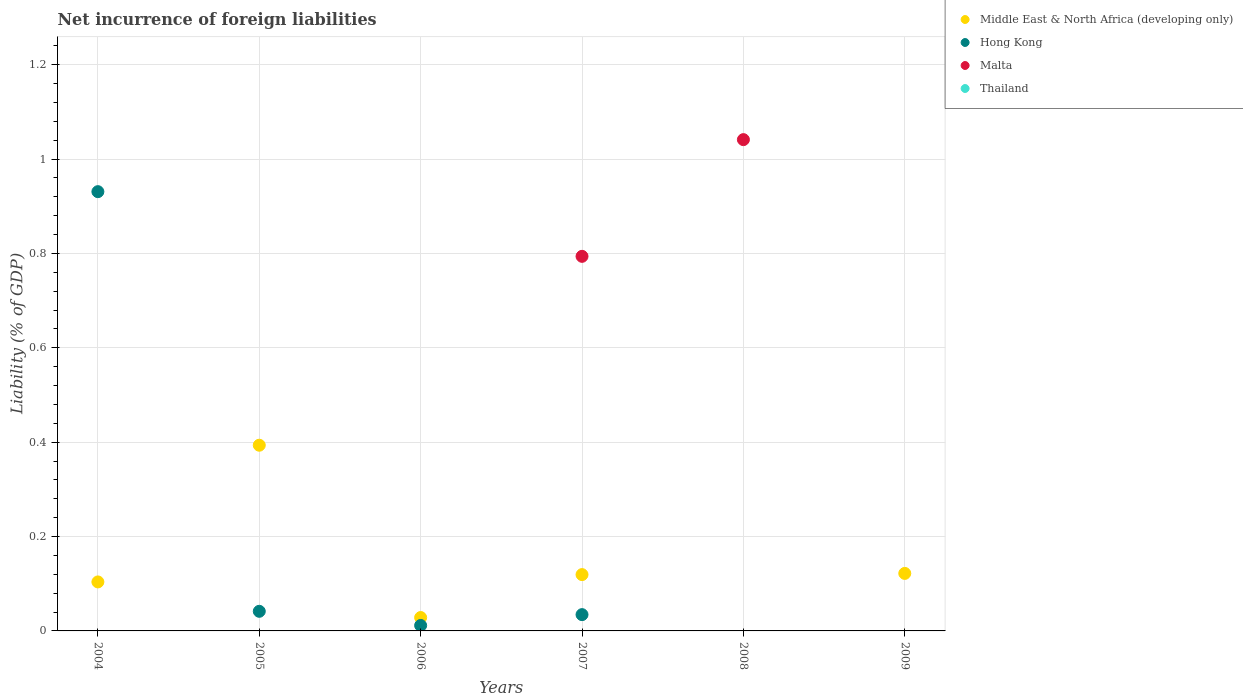How many different coloured dotlines are there?
Your response must be concise. 3. Is the number of dotlines equal to the number of legend labels?
Keep it short and to the point. No. What is the net incurrence of foreign liabilities in Middle East & North Africa (developing only) in 2004?
Your answer should be very brief. 0.1. Across all years, what is the maximum net incurrence of foreign liabilities in Malta?
Your response must be concise. 1.04. In which year was the net incurrence of foreign liabilities in Hong Kong maximum?
Offer a very short reply. 2004. What is the total net incurrence of foreign liabilities in Middle East & North Africa (developing only) in the graph?
Your answer should be compact. 0.77. What is the difference between the net incurrence of foreign liabilities in Middle East & North Africa (developing only) in 2004 and that in 2007?
Your answer should be compact. -0.02. What is the difference between the net incurrence of foreign liabilities in Middle East & North Africa (developing only) in 2006 and the net incurrence of foreign liabilities in Hong Kong in 2007?
Ensure brevity in your answer.  -0.01. What is the average net incurrence of foreign liabilities in Middle East & North Africa (developing only) per year?
Ensure brevity in your answer.  0.13. In the year 2007, what is the difference between the net incurrence of foreign liabilities in Middle East & North Africa (developing only) and net incurrence of foreign liabilities in Hong Kong?
Give a very brief answer. 0.08. What is the ratio of the net incurrence of foreign liabilities in Middle East & North Africa (developing only) in 2004 to that in 2007?
Offer a terse response. 0.87. Is the net incurrence of foreign liabilities in Middle East & North Africa (developing only) in 2005 less than that in 2009?
Your answer should be compact. No. What is the difference between the highest and the second highest net incurrence of foreign liabilities in Hong Kong?
Give a very brief answer. 0.89. What is the difference between the highest and the lowest net incurrence of foreign liabilities in Middle East & North Africa (developing only)?
Offer a very short reply. 0.39. Is the sum of the net incurrence of foreign liabilities in Hong Kong in 2006 and 2007 greater than the maximum net incurrence of foreign liabilities in Malta across all years?
Offer a terse response. No. Is it the case that in every year, the sum of the net incurrence of foreign liabilities in Thailand and net incurrence of foreign liabilities in Malta  is greater than the sum of net incurrence of foreign liabilities in Hong Kong and net incurrence of foreign liabilities in Middle East & North Africa (developing only)?
Your answer should be very brief. No. Does the net incurrence of foreign liabilities in Malta monotonically increase over the years?
Provide a short and direct response. No. What is the difference between two consecutive major ticks on the Y-axis?
Make the answer very short. 0.2. Does the graph contain any zero values?
Your answer should be very brief. Yes. Where does the legend appear in the graph?
Provide a succinct answer. Top right. How many legend labels are there?
Provide a succinct answer. 4. How are the legend labels stacked?
Ensure brevity in your answer.  Vertical. What is the title of the graph?
Your answer should be very brief. Net incurrence of foreign liabilities. Does "El Salvador" appear as one of the legend labels in the graph?
Provide a succinct answer. No. What is the label or title of the Y-axis?
Offer a very short reply. Liability (% of GDP). What is the Liability (% of GDP) in Middle East & North Africa (developing only) in 2004?
Your answer should be very brief. 0.1. What is the Liability (% of GDP) of Hong Kong in 2004?
Provide a succinct answer. 0.93. What is the Liability (% of GDP) of Middle East & North Africa (developing only) in 2005?
Give a very brief answer. 0.39. What is the Liability (% of GDP) of Hong Kong in 2005?
Provide a succinct answer. 0.04. What is the Liability (% of GDP) in Thailand in 2005?
Offer a terse response. 0. What is the Liability (% of GDP) of Middle East & North Africa (developing only) in 2006?
Offer a terse response. 0.03. What is the Liability (% of GDP) of Hong Kong in 2006?
Offer a very short reply. 0.01. What is the Liability (% of GDP) of Thailand in 2006?
Give a very brief answer. 0. What is the Liability (% of GDP) of Middle East & North Africa (developing only) in 2007?
Your answer should be compact. 0.12. What is the Liability (% of GDP) in Hong Kong in 2007?
Provide a succinct answer. 0.03. What is the Liability (% of GDP) in Malta in 2007?
Your response must be concise. 0.79. What is the Liability (% of GDP) in Middle East & North Africa (developing only) in 2008?
Offer a terse response. 0. What is the Liability (% of GDP) of Hong Kong in 2008?
Offer a very short reply. 0. What is the Liability (% of GDP) in Malta in 2008?
Offer a terse response. 1.04. What is the Liability (% of GDP) in Middle East & North Africa (developing only) in 2009?
Your response must be concise. 0.12. What is the Liability (% of GDP) of Hong Kong in 2009?
Keep it short and to the point. 0. Across all years, what is the maximum Liability (% of GDP) in Middle East & North Africa (developing only)?
Your answer should be very brief. 0.39. Across all years, what is the maximum Liability (% of GDP) in Hong Kong?
Your answer should be very brief. 0.93. Across all years, what is the maximum Liability (% of GDP) in Malta?
Ensure brevity in your answer.  1.04. Across all years, what is the minimum Liability (% of GDP) of Middle East & North Africa (developing only)?
Your response must be concise. 0. What is the total Liability (% of GDP) in Middle East & North Africa (developing only) in the graph?
Keep it short and to the point. 0.77. What is the total Liability (% of GDP) in Hong Kong in the graph?
Ensure brevity in your answer.  1.02. What is the total Liability (% of GDP) of Malta in the graph?
Give a very brief answer. 1.84. What is the difference between the Liability (% of GDP) of Middle East & North Africa (developing only) in 2004 and that in 2005?
Offer a very short reply. -0.29. What is the difference between the Liability (% of GDP) of Hong Kong in 2004 and that in 2005?
Ensure brevity in your answer.  0.89. What is the difference between the Liability (% of GDP) of Middle East & North Africa (developing only) in 2004 and that in 2006?
Make the answer very short. 0.08. What is the difference between the Liability (% of GDP) of Hong Kong in 2004 and that in 2006?
Offer a very short reply. 0.92. What is the difference between the Liability (% of GDP) in Middle East & North Africa (developing only) in 2004 and that in 2007?
Ensure brevity in your answer.  -0.02. What is the difference between the Liability (% of GDP) of Hong Kong in 2004 and that in 2007?
Provide a succinct answer. 0.9. What is the difference between the Liability (% of GDP) of Middle East & North Africa (developing only) in 2004 and that in 2009?
Make the answer very short. -0.02. What is the difference between the Liability (% of GDP) in Middle East & North Africa (developing only) in 2005 and that in 2006?
Keep it short and to the point. 0.37. What is the difference between the Liability (% of GDP) of Hong Kong in 2005 and that in 2006?
Your answer should be very brief. 0.03. What is the difference between the Liability (% of GDP) in Middle East & North Africa (developing only) in 2005 and that in 2007?
Your answer should be compact. 0.27. What is the difference between the Liability (% of GDP) in Hong Kong in 2005 and that in 2007?
Offer a very short reply. 0.01. What is the difference between the Liability (% of GDP) in Middle East & North Africa (developing only) in 2005 and that in 2009?
Keep it short and to the point. 0.27. What is the difference between the Liability (% of GDP) of Middle East & North Africa (developing only) in 2006 and that in 2007?
Give a very brief answer. -0.09. What is the difference between the Liability (% of GDP) in Hong Kong in 2006 and that in 2007?
Make the answer very short. -0.02. What is the difference between the Liability (% of GDP) in Middle East & North Africa (developing only) in 2006 and that in 2009?
Your response must be concise. -0.09. What is the difference between the Liability (% of GDP) in Malta in 2007 and that in 2008?
Give a very brief answer. -0.25. What is the difference between the Liability (% of GDP) of Middle East & North Africa (developing only) in 2007 and that in 2009?
Give a very brief answer. -0. What is the difference between the Liability (% of GDP) in Middle East & North Africa (developing only) in 2004 and the Liability (% of GDP) in Hong Kong in 2005?
Offer a very short reply. 0.06. What is the difference between the Liability (% of GDP) of Middle East & North Africa (developing only) in 2004 and the Liability (% of GDP) of Hong Kong in 2006?
Your response must be concise. 0.09. What is the difference between the Liability (% of GDP) of Middle East & North Africa (developing only) in 2004 and the Liability (% of GDP) of Hong Kong in 2007?
Provide a short and direct response. 0.07. What is the difference between the Liability (% of GDP) of Middle East & North Africa (developing only) in 2004 and the Liability (% of GDP) of Malta in 2007?
Provide a succinct answer. -0.69. What is the difference between the Liability (% of GDP) in Hong Kong in 2004 and the Liability (% of GDP) in Malta in 2007?
Offer a very short reply. 0.14. What is the difference between the Liability (% of GDP) in Middle East & North Africa (developing only) in 2004 and the Liability (% of GDP) in Malta in 2008?
Your answer should be compact. -0.94. What is the difference between the Liability (% of GDP) of Hong Kong in 2004 and the Liability (% of GDP) of Malta in 2008?
Your answer should be very brief. -0.11. What is the difference between the Liability (% of GDP) of Middle East & North Africa (developing only) in 2005 and the Liability (% of GDP) of Hong Kong in 2006?
Give a very brief answer. 0.38. What is the difference between the Liability (% of GDP) in Middle East & North Africa (developing only) in 2005 and the Liability (% of GDP) in Hong Kong in 2007?
Provide a succinct answer. 0.36. What is the difference between the Liability (% of GDP) in Middle East & North Africa (developing only) in 2005 and the Liability (% of GDP) in Malta in 2007?
Ensure brevity in your answer.  -0.4. What is the difference between the Liability (% of GDP) in Hong Kong in 2005 and the Liability (% of GDP) in Malta in 2007?
Provide a succinct answer. -0.75. What is the difference between the Liability (% of GDP) of Middle East & North Africa (developing only) in 2005 and the Liability (% of GDP) of Malta in 2008?
Provide a short and direct response. -0.65. What is the difference between the Liability (% of GDP) of Hong Kong in 2005 and the Liability (% of GDP) of Malta in 2008?
Your answer should be compact. -1. What is the difference between the Liability (% of GDP) of Middle East & North Africa (developing only) in 2006 and the Liability (% of GDP) of Hong Kong in 2007?
Offer a terse response. -0.01. What is the difference between the Liability (% of GDP) in Middle East & North Africa (developing only) in 2006 and the Liability (% of GDP) in Malta in 2007?
Give a very brief answer. -0.77. What is the difference between the Liability (% of GDP) in Hong Kong in 2006 and the Liability (% of GDP) in Malta in 2007?
Offer a terse response. -0.78. What is the difference between the Liability (% of GDP) of Middle East & North Africa (developing only) in 2006 and the Liability (% of GDP) of Malta in 2008?
Ensure brevity in your answer.  -1.01. What is the difference between the Liability (% of GDP) in Hong Kong in 2006 and the Liability (% of GDP) in Malta in 2008?
Give a very brief answer. -1.03. What is the difference between the Liability (% of GDP) in Middle East & North Africa (developing only) in 2007 and the Liability (% of GDP) in Malta in 2008?
Offer a very short reply. -0.92. What is the difference between the Liability (% of GDP) in Hong Kong in 2007 and the Liability (% of GDP) in Malta in 2008?
Offer a terse response. -1.01. What is the average Liability (% of GDP) in Middle East & North Africa (developing only) per year?
Your response must be concise. 0.13. What is the average Liability (% of GDP) of Hong Kong per year?
Make the answer very short. 0.17. What is the average Liability (% of GDP) in Malta per year?
Provide a short and direct response. 0.31. In the year 2004, what is the difference between the Liability (% of GDP) of Middle East & North Africa (developing only) and Liability (% of GDP) of Hong Kong?
Your answer should be compact. -0.83. In the year 2005, what is the difference between the Liability (% of GDP) in Middle East & North Africa (developing only) and Liability (% of GDP) in Hong Kong?
Offer a terse response. 0.35. In the year 2006, what is the difference between the Liability (% of GDP) in Middle East & North Africa (developing only) and Liability (% of GDP) in Hong Kong?
Make the answer very short. 0.02. In the year 2007, what is the difference between the Liability (% of GDP) in Middle East & North Africa (developing only) and Liability (% of GDP) in Hong Kong?
Offer a very short reply. 0.08. In the year 2007, what is the difference between the Liability (% of GDP) in Middle East & North Africa (developing only) and Liability (% of GDP) in Malta?
Provide a succinct answer. -0.67. In the year 2007, what is the difference between the Liability (% of GDP) of Hong Kong and Liability (% of GDP) of Malta?
Give a very brief answer. -0.76. What is the ratio of the Liability (% of GDP) of Middle East & North Africa (developing only) in 2004 to that in 2005?
Provide a short and direct response. 0.26. What is the ratio of the Liability (% of GDP) of Hong Kong in 2004 to that in 2005?
Your response must be concise. 22.4. What is the ratio of the Liability (% of GDP) in Middle East & North Africa (developing only) in 2004 to that in 2006?
Keep it short and to the point. 3.66. What is the ratio of the Liability (% of GDP) in Hong Kong in 2004 to that in 2006?
Your answer should be very brief. 80.44. What is the ratio of the Liability (% of GDP) of Middle East & North Africa (developing only) in 2004 to that in 2007?
Your answer should be very brief. 0.87. What is the ratio of the Liability (% of GDP) in Hong Kong in 2004 to that in 2007?
Make the answer very short. 26.96. What is the ratio of the Liability (% of GDP) in Middle East & North Africa (developing only) in 2004 to that in 2009?
Your answer should be compact. 0.85. What is the ratio of the Liability (% of GDP) in Middle East & North Africa (developing only) in 2005 to that in 2006?
Offer a terse response. 13.87. What is the ratio of the Liability (% of GDP) in Hong Kong in 2005 to that in 2006?
Your answer should be compact. 3.59. What is the ratio of the Liability (% of GDP) in Middle East & North Africa (developing only) in 2005 to that in 2007?
Offer a very short reply. 3.3. What is the ratio of the Liability (% of GDP) of Hong Kong in 2005 to that in 2007?
Give a very brief answer. 1.2. What is the ratio of the Liability (% of GDP) in Middle East & North Africa (developing only) in 2005 to that in 2009?
Keep it short and to the point. 3.23. What is the ratio of the Liability (% of GDP) of Middle East & North Africa (developing only) in 2006 to that in 2007?
Your response must be concise. 0.24. What is the ratio of the Liability (% of GDP) of Hong Kong in 2006 to that in 2007?
Provide a succinct answer. 0.34. What is the ratio of the Liability (% of GDP) in Middle East & North Africa (developing only) in 2006 to that in 2009?
Offer a very short reply. 0.23. What is the ratio of the Liability (% of GDP) of Malta in 2007 to that in 2008?
Keep it short and to the point. 0.76. What is the ratio of the Liability (% of GDP) in Middle East & North Africa (developing only) in 2007 to that in 2009?
Ensure brevity in your answer.  0.98. What is the difference between the highest and the second highest Liability (% of GDP) in Middle East & North Africa (developing only)?
Give a very brief answer. 0.27. What is the difference between the highest and the second highest Liability (% of GDP) of Hong Kong?
Ensure brevity in your answer.  0.89. What is the difference between the highest and the lowest Liability (% of GDP) in Middle East & North Africa (developing only)?
Your answer should be compact. 0.39. What is the difference between the highest and the lowest Liability (% of GDP) in Hong Kong?
Your answer should be very brief. 0.93. What is the difference between the highest and the lowest Liability (% of GDP) in Malta?
Offer a terse response. 1.04. 